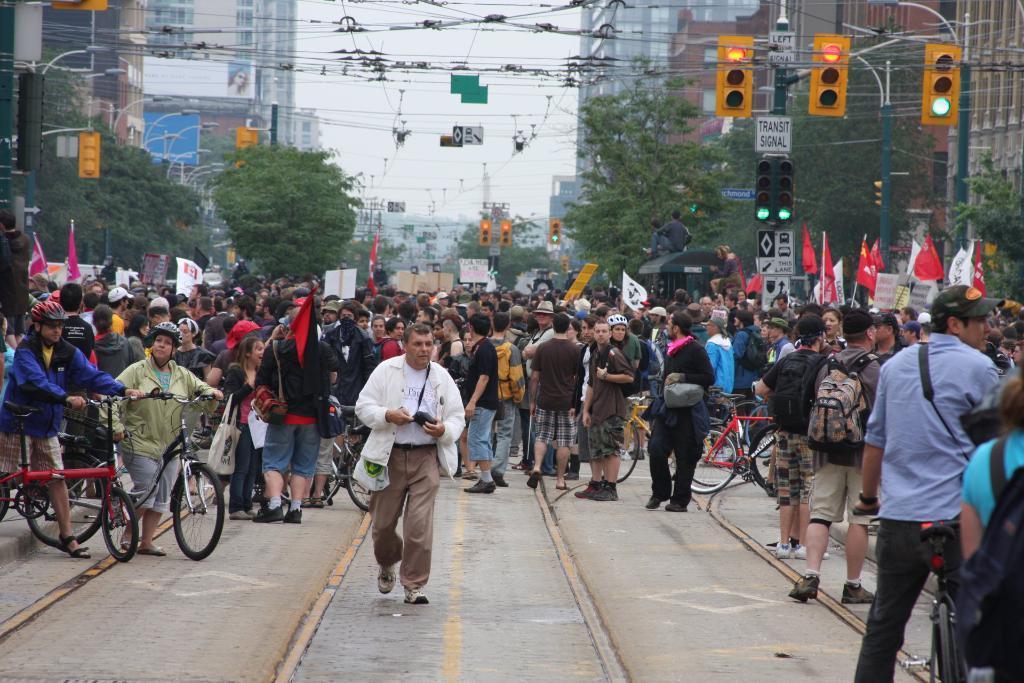How would you summarize this image in a sentence or two? This picture shows few people standing and a person walking and we se couple of bicycles and a few buildings around and trees and traffic lights 